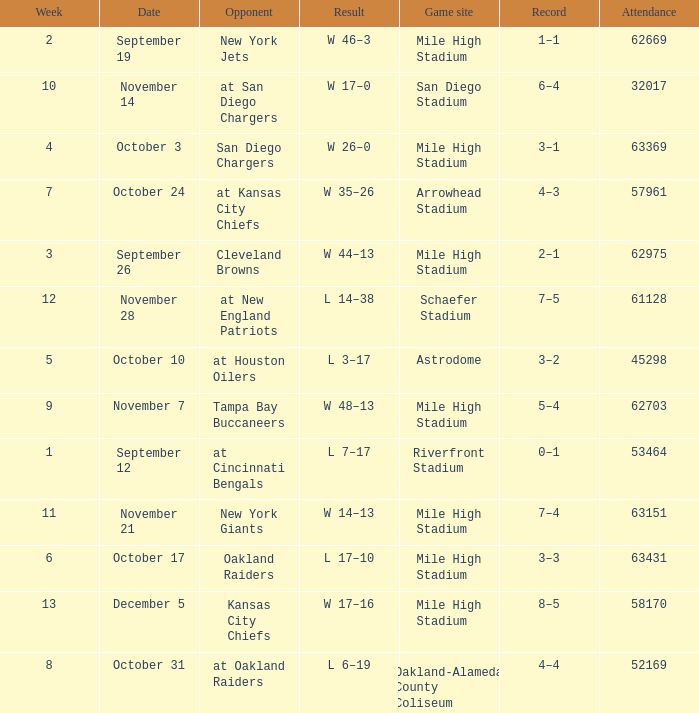Parse the full table. {'header': ['Week', 'Date', 'Opponent', 'Result', 'Game site', 'Record', 'Attendance'], 'rows': [['2', 'September 19', 'New York Jets', 'W 46–3', 'Mile High Stadium', '1–1', '62669'], ['10', 'November 14', 'at San Diego Chargers', 'W 17–0', 'San Diego Stadium', '6–4', '32017'], ['4', 'October 3', 'San Diego Chargers', 'W 26–0', 'Mile High Stadium', '3–1', '63369'], ['7', 'October 24', 'at Kansas City Chiefs', 'W 35–26', 'Arrowhead Stadium', '4–3', '57961'], ['3', 'September 26', 'Cleveland Browns', 'W 44–13', 'Mile High Stadium', '2–1', '62975'], ['12', 'November 28', 'at New England Patriots', 'L 14–38', 'Schaefer Stadium', '7–5', '61128'], ['5', 'October 10', 'at Houston Oilers', 'L 3–17', 'Astrodome', '3–2', '45298'], ['9', 'November 7', 'Tampa Bay Buccaneers', 'W 48–13', 'Mile High Stadium', '5–4', '62703'], ['1', 'September 12', 'at Cincinnati Bengals', 'L 7–17', 'Riverfront Stadium', '0–1', '53464'], ['11', 'November 21', 'New York Giants', 'W 14–13', 'Mile High Stadium', '7–4', '63151'], ['6', 'October 17', 'Oakland Raiders', 'L 17–10', 'Mile High Stadium', '3–3', '63431'], ['13', 'December 5', 'Kansas City Chiefs', 'W 17–16', 'Mile High Stadium', '8–5', '58170'], ['8', 'October 31', 'at Oakland Raiders', 'L 6–19', 'Oakland-Alameda County Coliseum', '4–4', '52169']]} What was the week number when the opponent was the New York Jets? 2.0. 